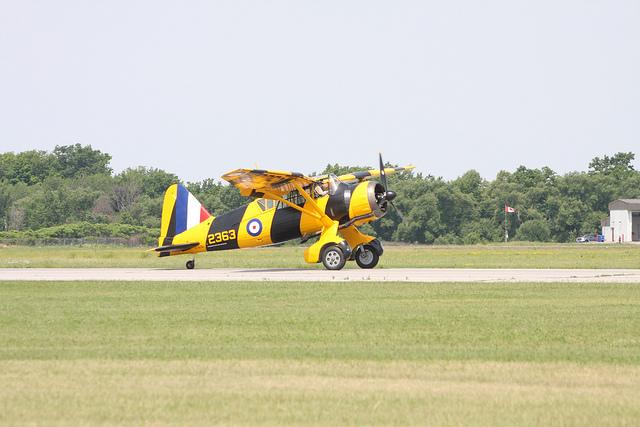What famous pilot is this plane usually associated with?
Answer briefly. Amelia earhart. What country's flag is represented on the tail fin?
Quick response, please. France. What type of plane is on the runway?
Concise answer only. Prop. What is the plane's tail number?
Quick response, please. 2363. 